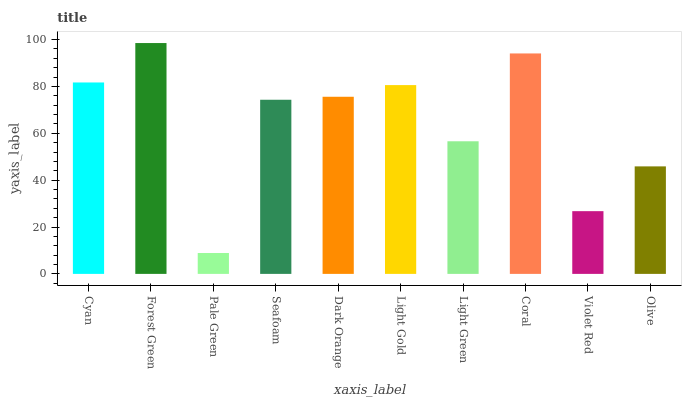Is Pale Green the minimum?
Answer yes or no. Yes. Is Forest Green the maximum?
Answer yes or no. Yes. Is Forest Green the minimum?
Answer yes or no. No. Is Pale Green the maximum?
Answer yes or no. No. Is Forest Green greater than Pale Green?
Answer yes or no. Yes. Is Pale Green less than Forest Green?
Answer yes or no. Yes. Is Pale Green greater than Forest Green?
Answer yes or no. No. Is Forest Green less than Pale Green?
Answer yes or no. No. Is Dark Orange the high median?
Answer yes or no. Yes. Is Seafoam the low median?
Answer yes or no. Yes. Is Olive the high median?
Answer yes or no. No. Is Light Gold the low median?
Answer yes or no. No. 